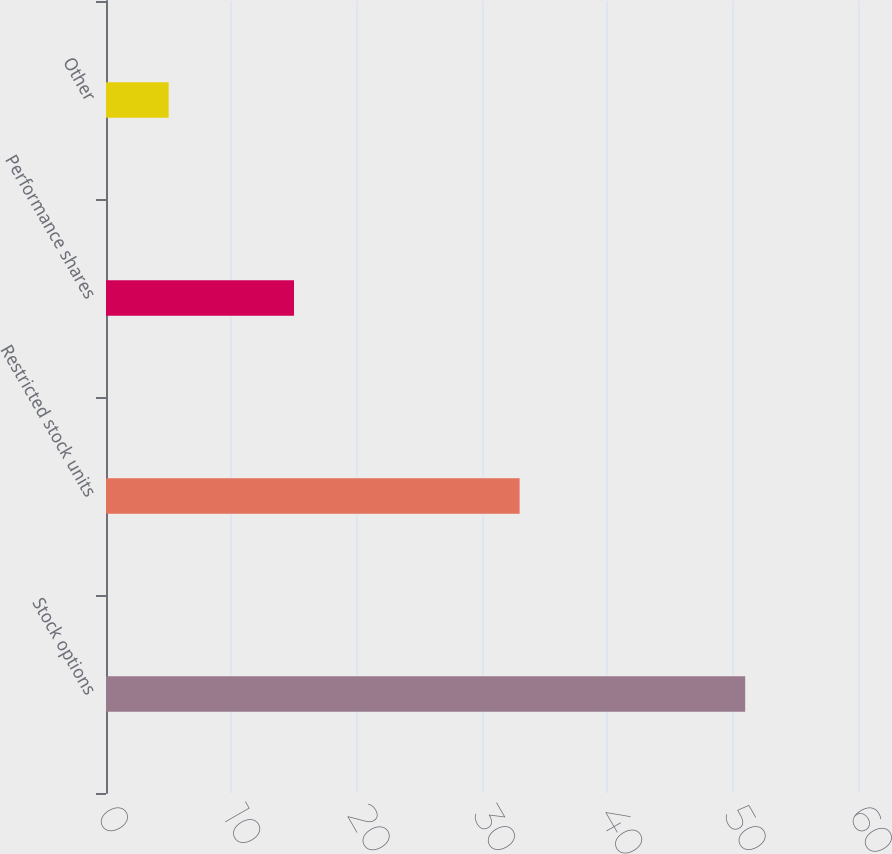Convert chart to OTSL. <chart><loc_0><loc_0><loc_500><loc_500><bar_chart><fcel>Stock options<fcel>Restricted stock units<fcel>Performance shares<fcel>Other<nl><fcel>51<fcel>33<fcel>15<fcel>5<nl></chart> 